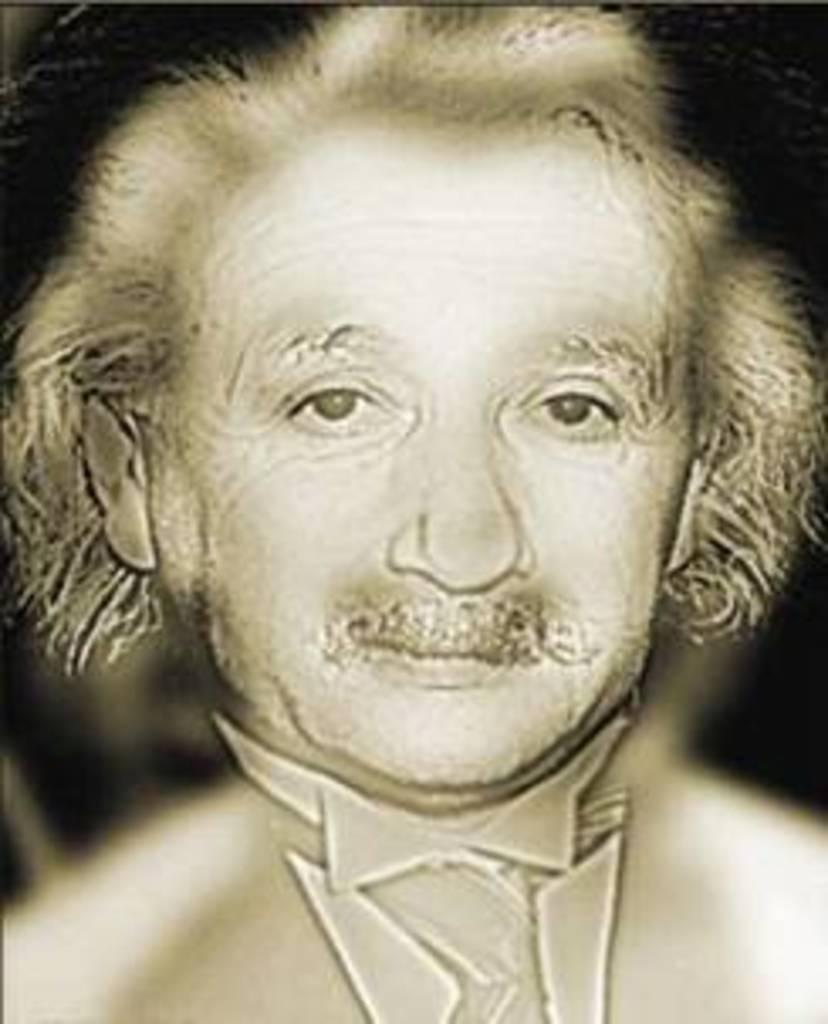What is the main subject of the image? There is a painting of a person in the image. What type of amusement can be seen in the painting? There is no amusement present in the painting; it is a portrait of a person. How many women are depicted in the painting? There is no woman depicted in the painting; it is a portrait of a person, but the gender is not specified. 